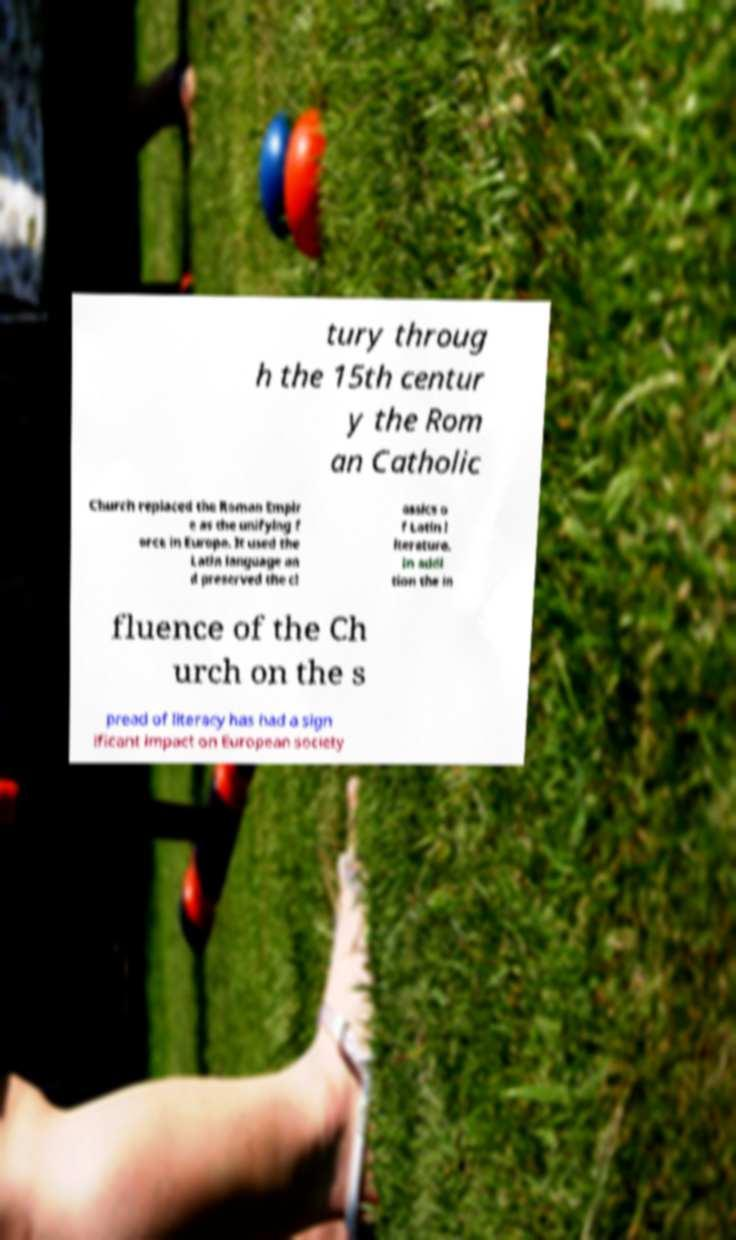There's text embedded in this image that I need extracted. Can you transcribe it verbatim? tury throug h the 15th centur y the Rom an Catholic Church replaced the Roman Empir e as the unifying f orce in Europe. It used the Latin language an d preserved the cl assics o f Latin l iterature. In addi tion the in fluence of the Ch urch on the s pread of literacy has had a sign ificant impact on European society 